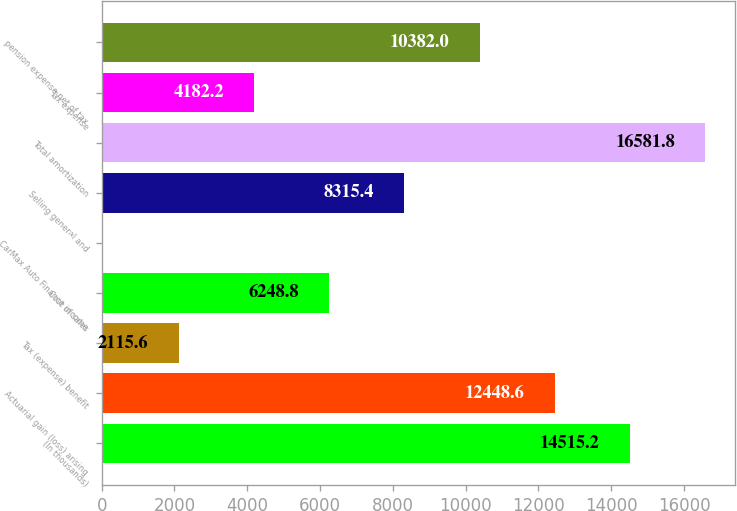Convert chart. <chart><loc_0><loc_0><loc_500><loc_500><bar_chart><fcel>(In thousands)<fcel>Actuarial gain (loss) arising<fcel>Tax (expense) benefit<fcel>Cost of sales<fcel>CarMax Auto Finance income<fcel>Selling general and<fcel>Total amortization<fcel>Tax expense<fcel>pension expense net of tax<nl><fcel>14515.2<fcel>12448.6<fcel>2115.6<fcel>6248.8<fcel>49<fcel>8315.4<fcel>16581.8<fcel>4182.2<fcel>10382<nl></chart> 